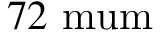<formula> <loc_0><loc_0><loc_500><loc_500>7 2 { \ m u m }</formula> 